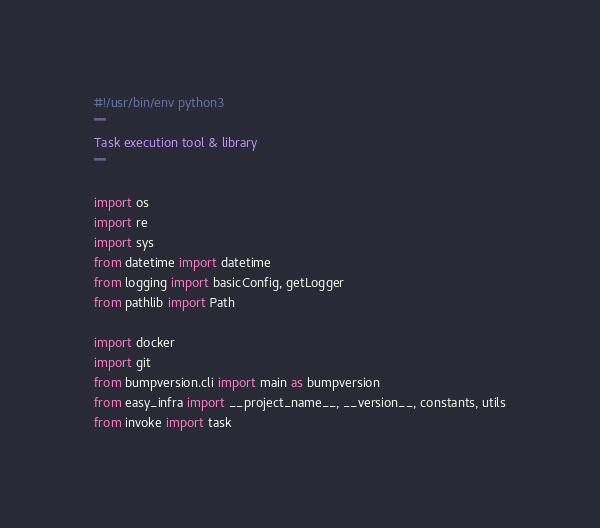<code> <loc_0><loc_0><loc_500><loc_500><_Python_>#!/usr/bin/env python3
"""
Task execution tool & library
"""

import os
import re
import sys
from datetime import datetime
from logging import basicConfig, getLogger
from pathlib import Path

import docker
import git
from bumpversion.cli import main as bumpversion
from easy_infra import __project_name__, __version__, constants, utils
from invoke import task</code> 